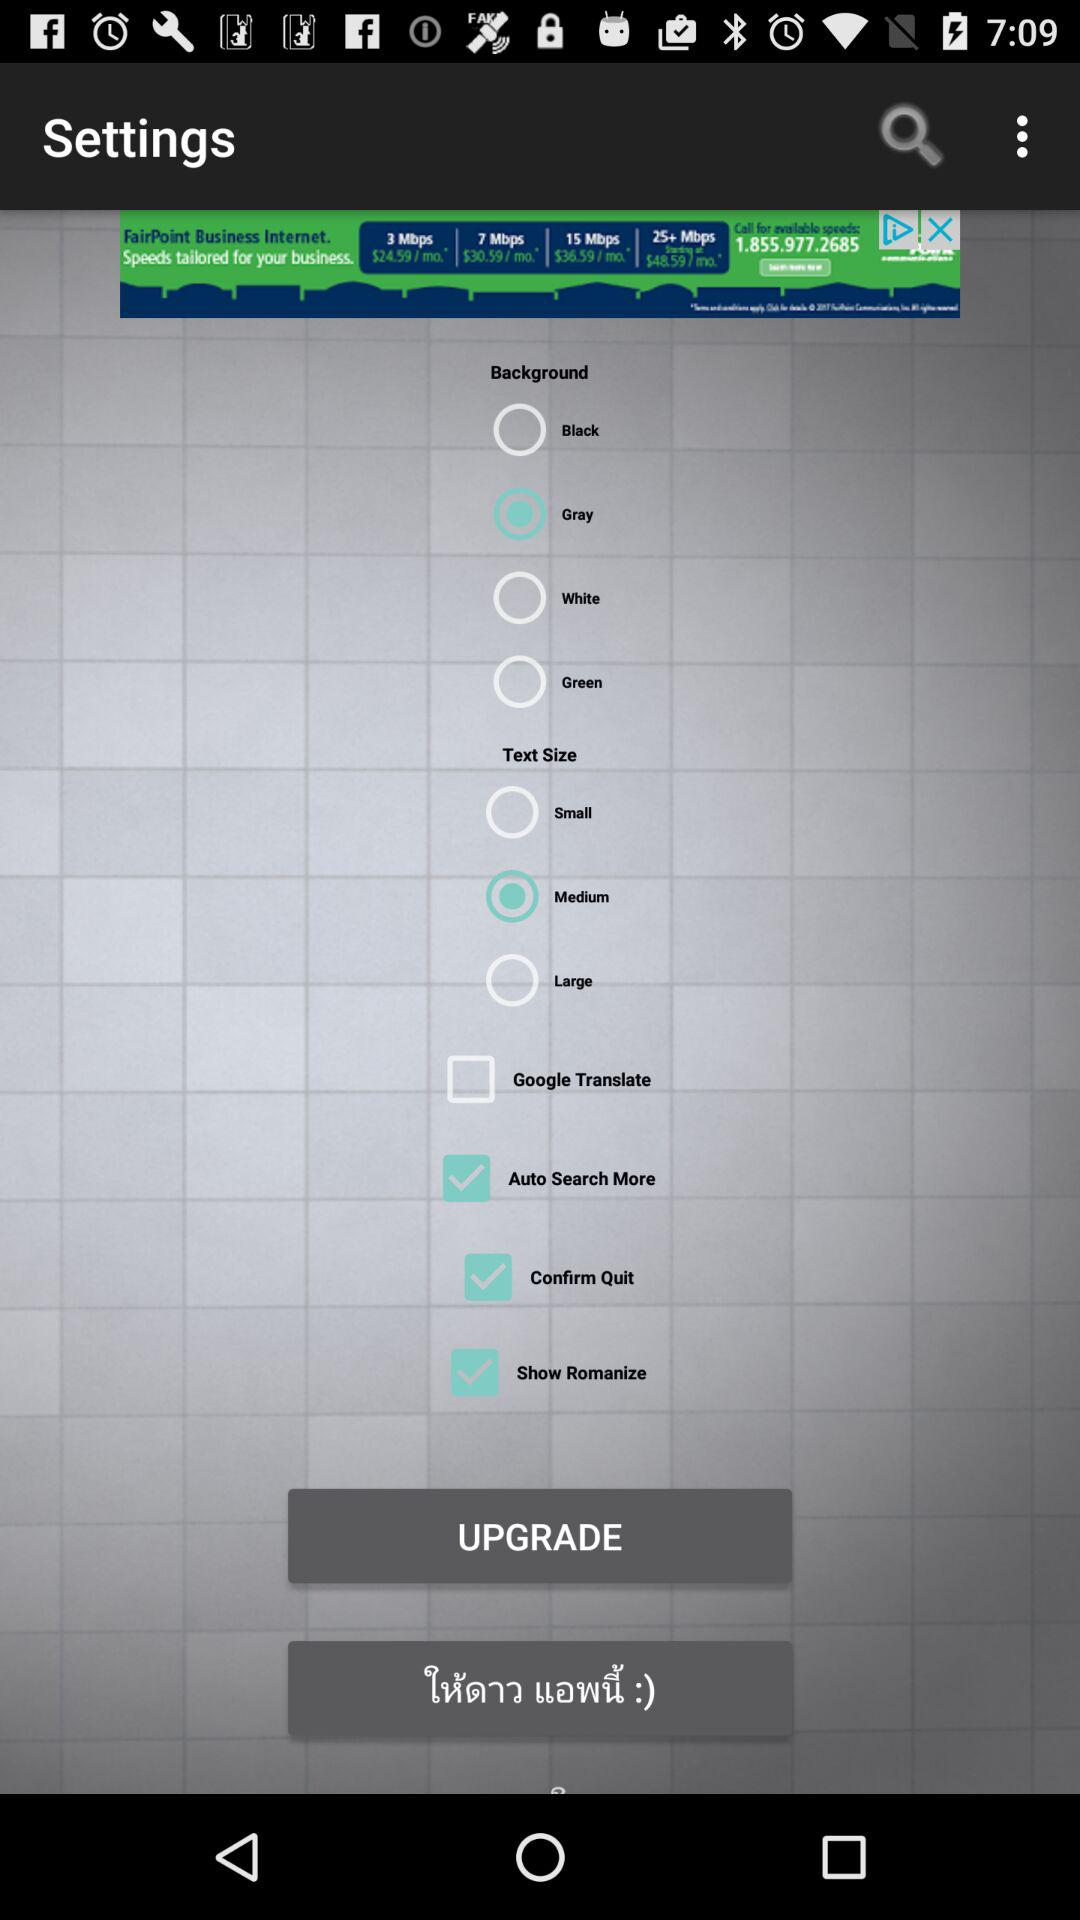What is the status of "Auto Search More"? The status is on. 